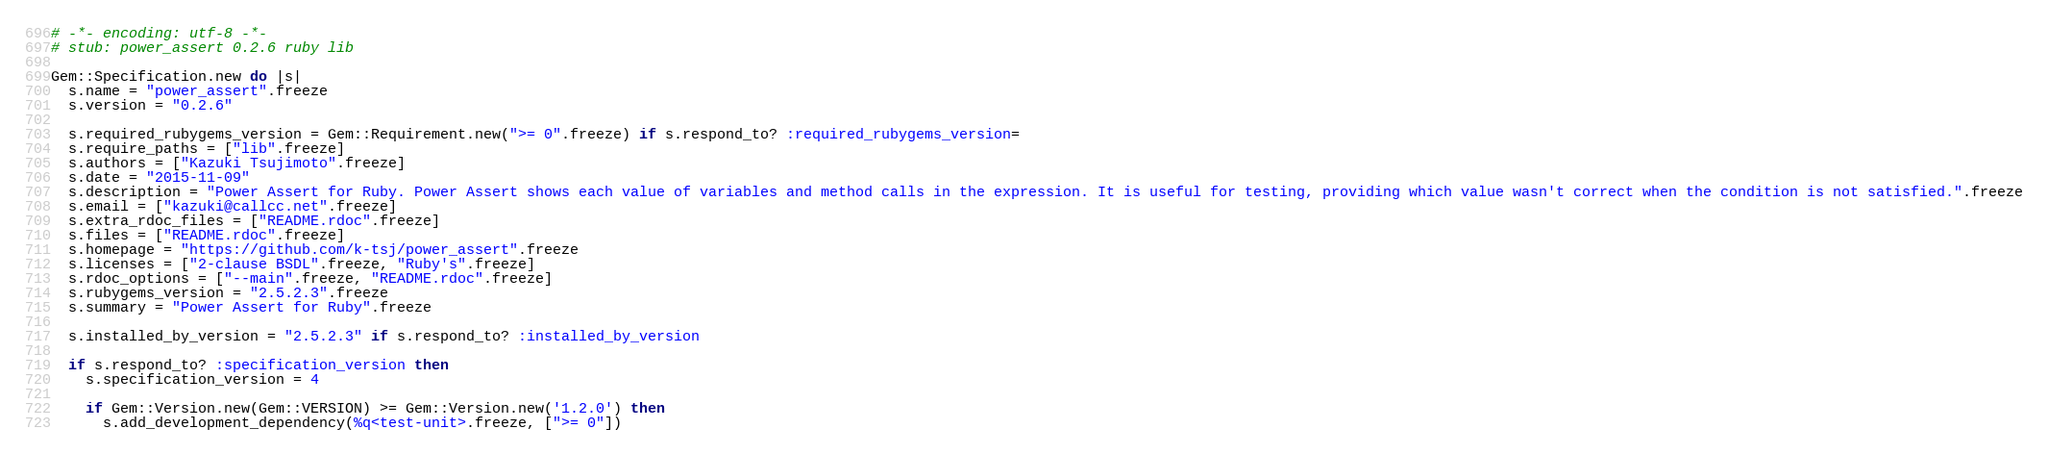Convert code to text. <code><loc_0><loc_0><loc_500><loc_500><_Ruby_># -*- encoding: utf-8 -*-
# stub: power_assert 0.2.6 ruby lib

Gem::Specification.new do |s|
  s.name = "power_assert".freeze
  s.version = "0.2.6"

  s.required_rubygems_version = Gem::Requirement.new(">= 0".freeze) if s.respond_to? :required_rubygems_version=
  s.require_paths = ["lib".freeze]
  s.authors = ["Kazuki Tsujimoto".freeze]
  s.date = "2015-11-09"
  s.description = "Power Assert for Ruby. Power Assert shows each value of variables and method calls in the expression. It is useful for testing, providing which value wasn't correct when the condition is not satisfied.".freeze
  s.email = ["kazuki@callcc.net".freeze]
  s.extra_rdoc_files = ["README.rdoc".freeze]
  s.files = ["README.rdoc".freeze]
  s.homepage = "https://github.com/k-tsj/power_assert".freeze
  s.licenses = ["2-clause BSDL".freeze, "Ruby's".freeze]
  s.rdoc_options = ["--main".freeze, "README.rdoc".freeze]
  s.rubygems_version = "2.5.2.3".freeze
  s.summary = "Power Assert for Ruby".freeze

  s.installed_by_version = "2.5.2.3" if s.respond_to? :installed_by_version

  if s.respond_to? :specification_version then
    s.specification_version = 4

    if Gem::Version.new(Gem::VERSION) >= Gem::Version.new('1.2.0') then
      s.add_development_dependency(%q<test-unit>.freeze, [">= 0"])</code> 